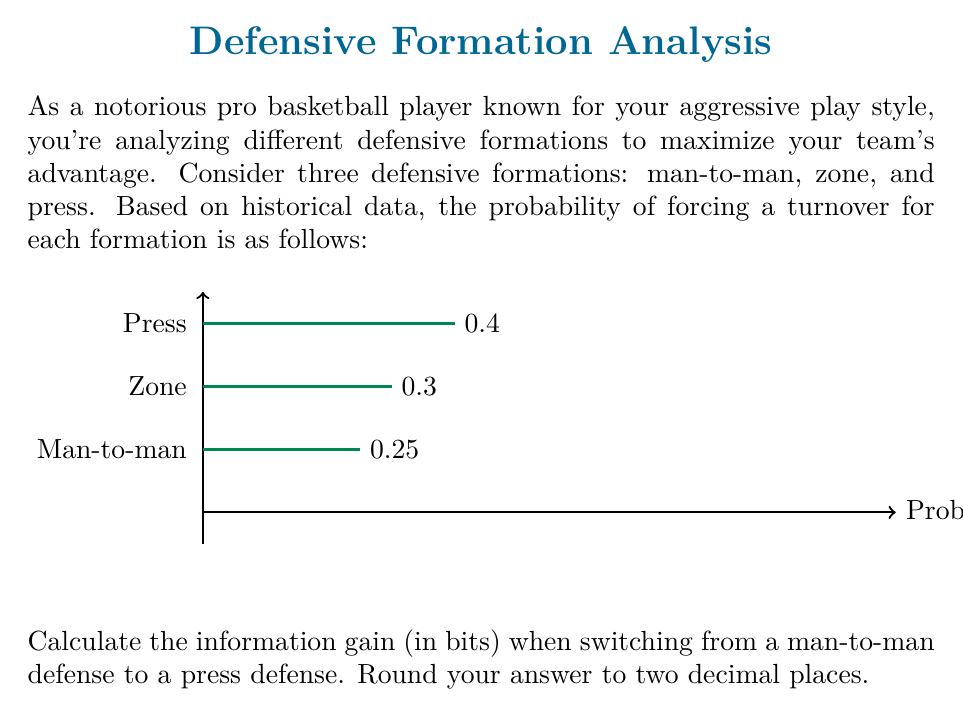Solve this math problem. To calculate the information gain when switching from man-to-man to press defense, we need to use the concept of entropy from information theory. The information gain is the difference in entropy between the two defensive formations.

Step 1: Calculate the entropy for man-to-man defense
Let $p_1 = 0.25$ be the probability of forcing a turnover in man-to-man defense.
The entropy is given by:
$$H_1 = -p_1 \log_2(p_1) - (1-p_1) \log_2(1-p_1)$$
$$H_1 = -0.25 \log_2(0.25) - 0.75 \log_2(0.75)$$
$$H_1 \approx 0.8113 \text{ bits}$$

Step 2: Calculate the entropy for press defense
Let $p_2 = 0.4$ be the probability of forcing a turnover in press defense.
The entropy is given by:
$$H_2 = -p_2 \log_2(p_2) - (1-p_2) \log_2(1-p_2)$$
$$H_2 = -0.4 \log_2(0.4) - 0.6 \log_2(0.6)$$
$$H_2 \approx 0.9710 \text{ bits}$$

Step 3: Calculate the information gain
The information gain is the difference between the two entropies:
$$\text{Information Gain} = H_2 - H_1$$
$$\text{Information Gain} = 0.9710 - 0.8113 = 0.1597 \text{ bits}$$

Rounding to two decimal places, we get 0.16 bits.
Answer: 0.16 bits 